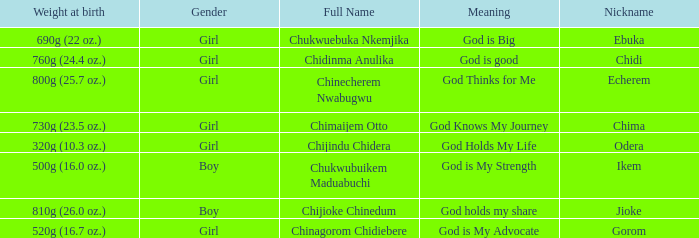Chukwubuikem Maduabuchi is what gender? Boy. 